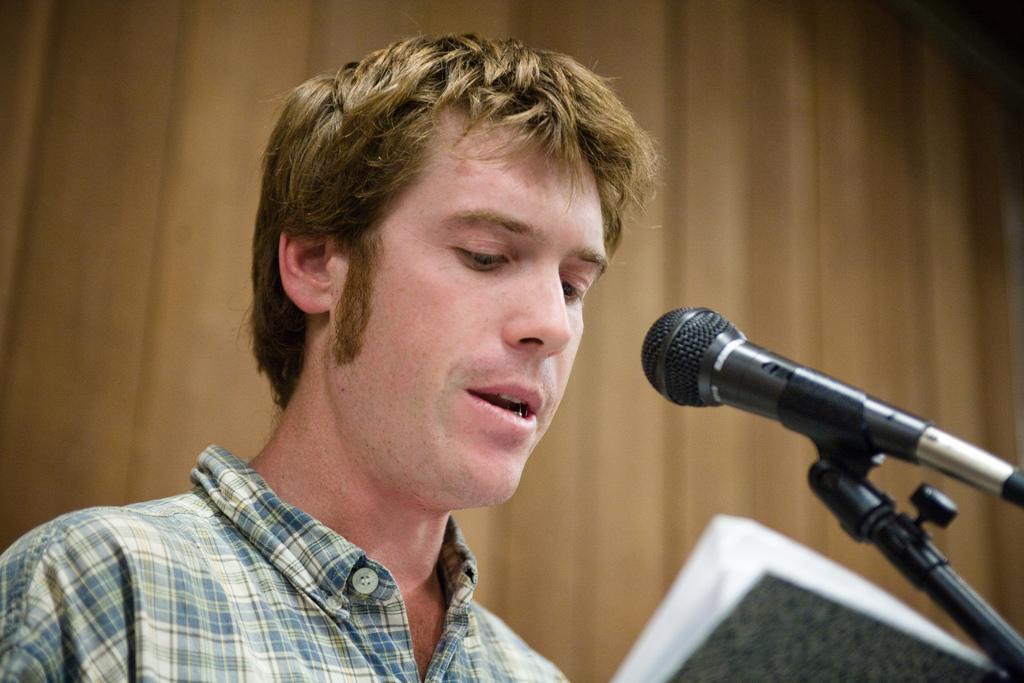Can you describe this image briefly? In this picture I can observe a man in the middle of the picture. In front of him there is a mic. The background is blurred. 